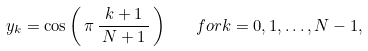<formula> <loc_0><loc_0><loc_500><loc_500>y _ { k } = \cos \left ( \, \pi \, { \frac { k + 1 } { \, N + 1 \, } } \, \right ) \quad { f o r } k = 0 , 1 , \dots , N - 1 ,</formula> 